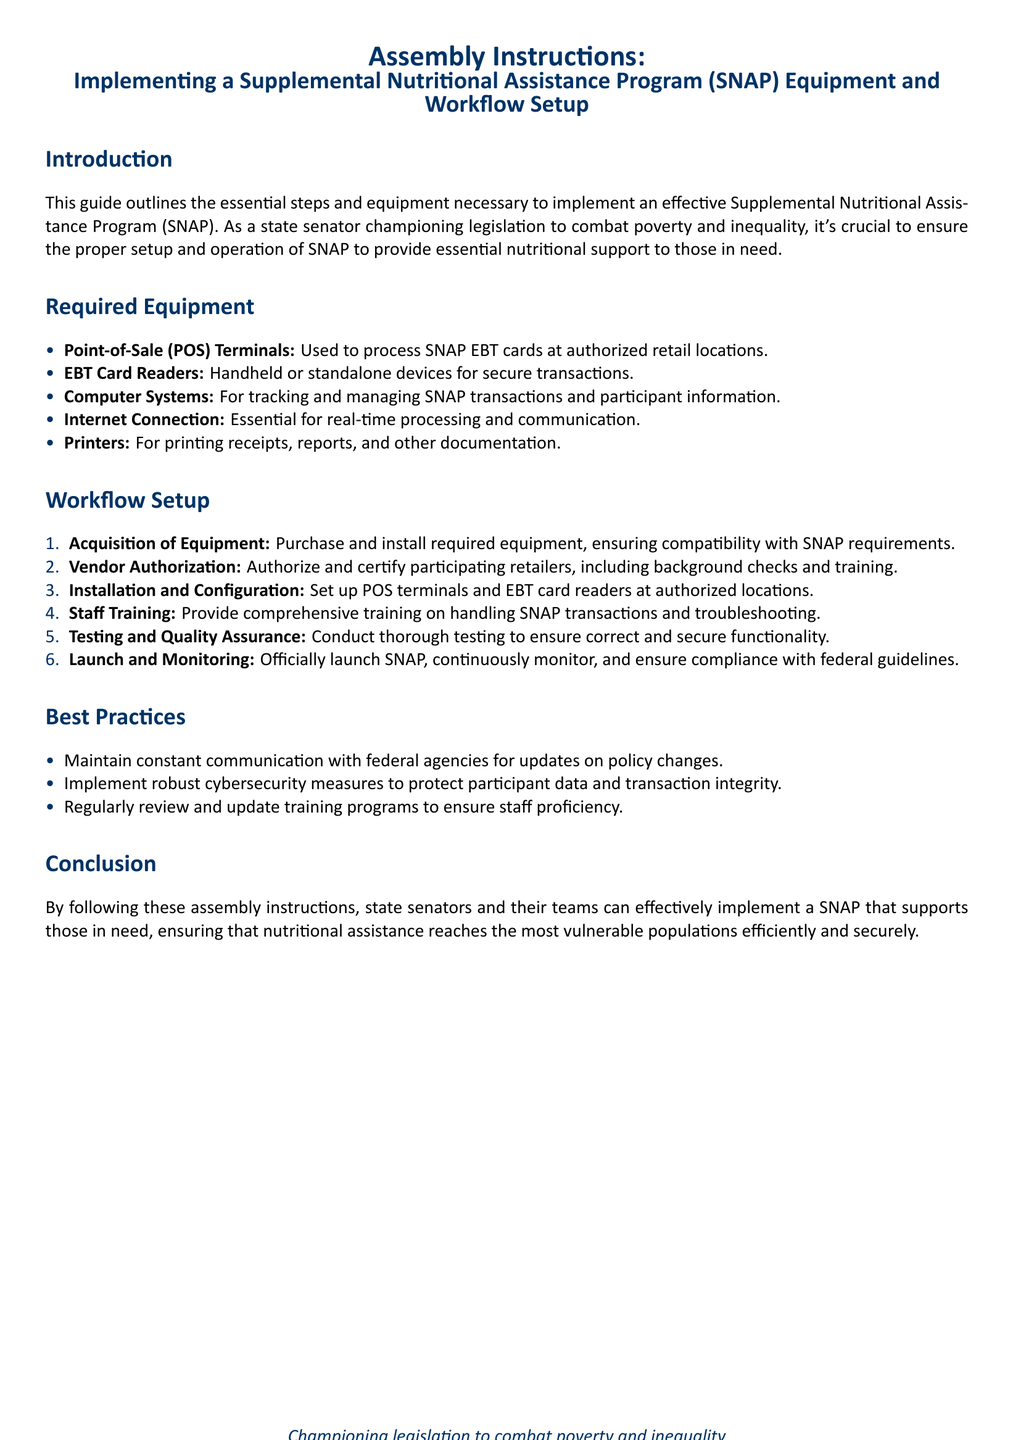What is the primary purpose of the document? The document provides assembly instructions for implementing a Supplemental Nutritional Assistance Program (SNAP) including equipment and workflow setup.
Answer: Supplemental Nutritional Assistance Program (SNAP) What equipment is needed for SNAP transactions? The required equipment section lists various necessary items for processing SNAP transactions such as POS terminals and EBT card readers.
Answer: Point-of-Sale (POS) Terminals How many steps are outlined in the workflow setup? The workflow setup section enumerates the steps required to implement SNAP and contains a total of six distinct steps.
Answer: 6 What is a key best practice mentioned in the document? The best practices section includes recommendations for maintaining communication with federal agencies for updates on policy changes.
Answer: Maintain constant communication with federal agencies What is the first step in the workflow setup? The first step listed in the workflow setup is focused on the acquisition of necessary equipment.
Answer: Acquisition of Equipment What color is used for the section titles? The document states a specific color for section titles in its formatting, which enhances readability and organization.
Answer: Dark blue What document type is this text categorized as? The layout and structure indicate this text serves as a guide or instructional document aimed at providing a clear process for implementation.
Answer: Assembly Instructions 